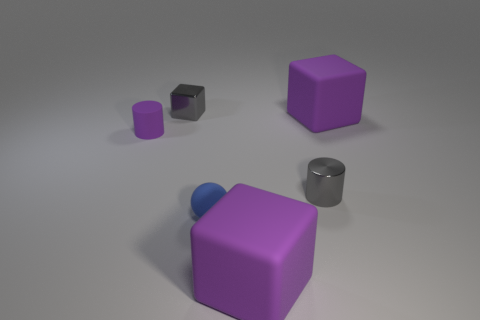Is the material of the purple object behind the tiny purple rubber object the same as the small blue ball?
Ensure brevity in your answer.  Yes. What number of objects are either rubber things or large brown rubber blocks?
Offer a terse response. 4. What size is the gray shiny object that is the same shape as the small purple matte thing?
Give a very brief answer. Small. The gray metal cylinder has what size?
Your answer should be very brief. Small. Is the number of rubber objects to the right of the tiny blue object greater than the number of small matte spheres?
Give a very brief answer. Yes. Is there any other thing that has the same material as the ball?
Ensure brevity in your answer.  Yes. Does the big cube that is right of the small shiny cylinder have the same color as the rubber block that is in front of the gray metal cylinder?
Ensure brevity in your answer.  Yes. What material is the tiny object that is behind the matte cube that is behind the purple matte cube that is on the left side of the metal cylinder?
Ensure brevity in your answer.  Metal. Are there more big purple matte blocks than small shiny blocks?
Ensure brevity in your answer.  Yes. Is there any other thing of the same color as the tiny cube?
Your response must be concise. Yes. 